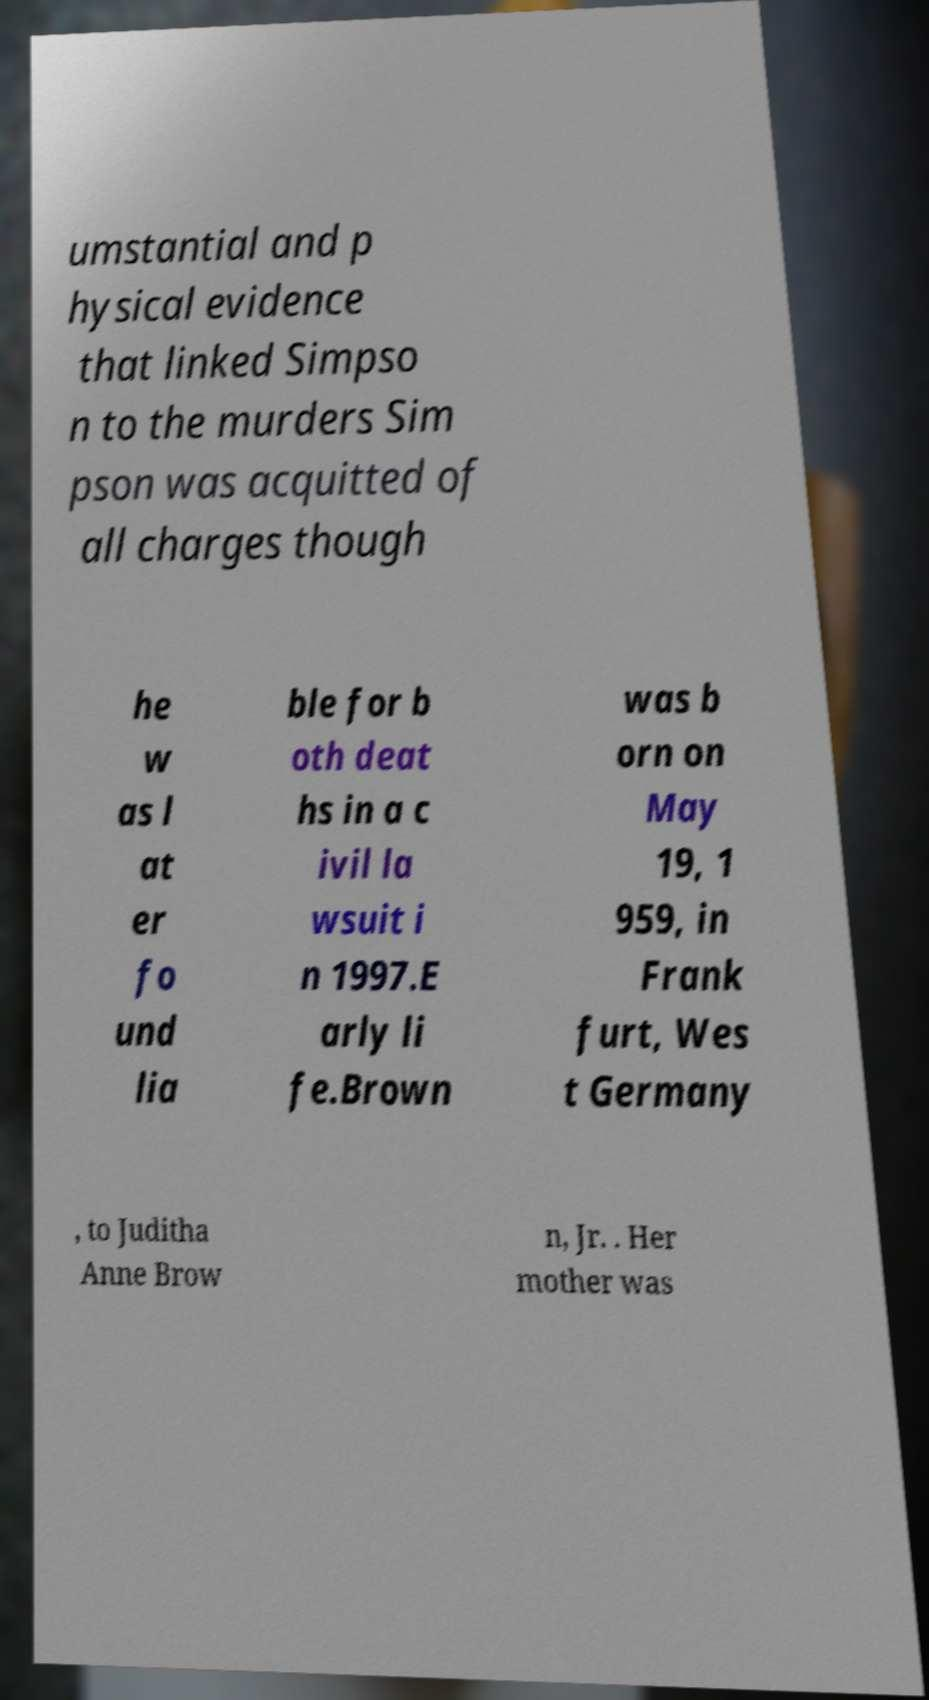Could you assist in decoding the text presented in this image and type it out clearly? umstantial and p hysical evidence that linked Simpso n to the murders Sim pson was acquitted of all charges though he w as l at er fo und lia ble for b oth deat hs in a c ivil la wsuit i n 1997.E arly li fe.Brown was b orn on May 19, 1 959, in Frank furt, Wes t Germany , to Juditha Anne Brow n, Jr. . Her mother was 